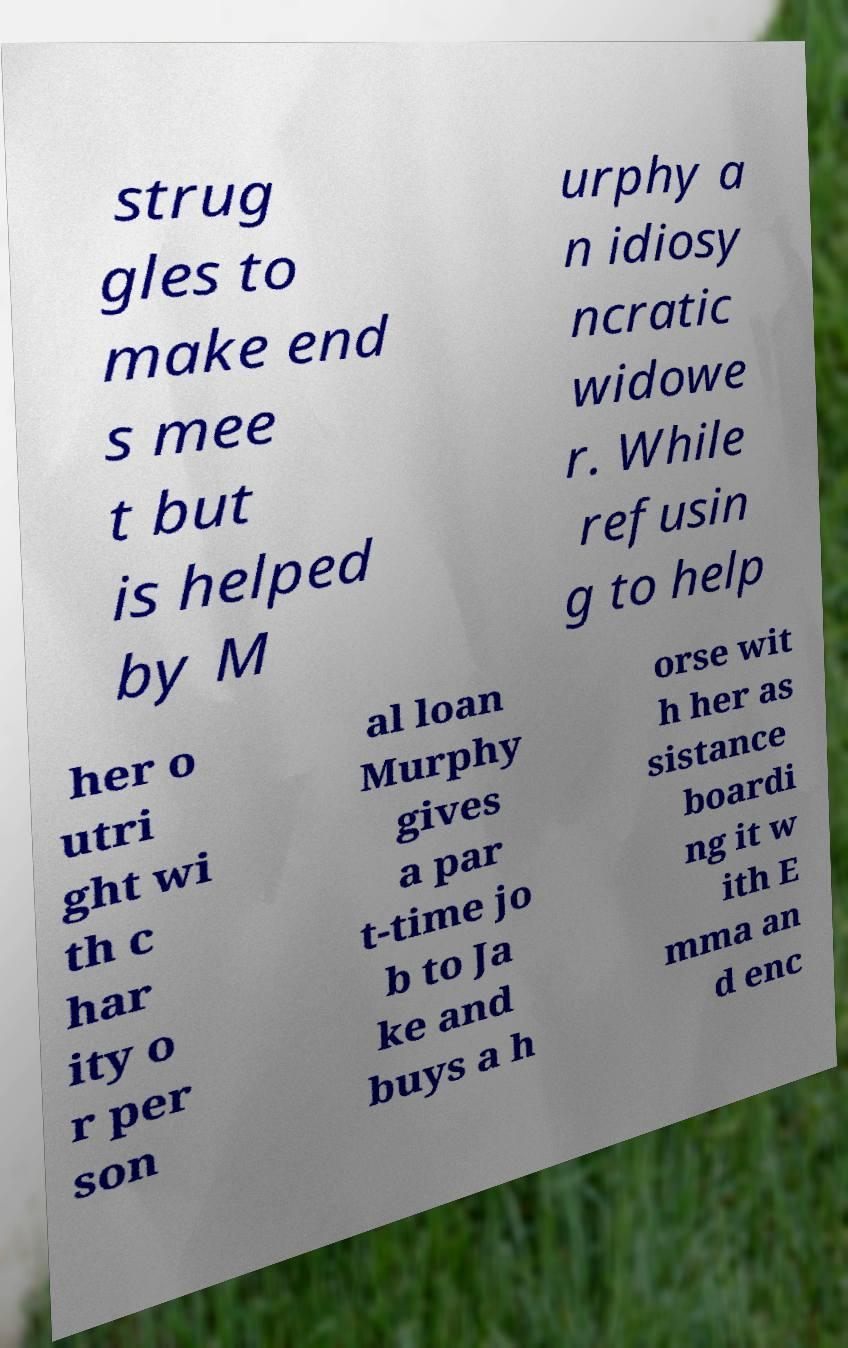Can you read and provide the text displayed in the image?This photo seems to have some interesting text. Can you extract and type it out for me? strug gles to make end s mee t but is helped by M urphy a n idiosy ncratic widowe r. While refusin g to help her o utri ght wi th c har ity o r per son al loan Murphy gives a par t-time jo b to Ja ke and buys a h orse wit h her as sistance boardi ng it w ith E mma an d enc 